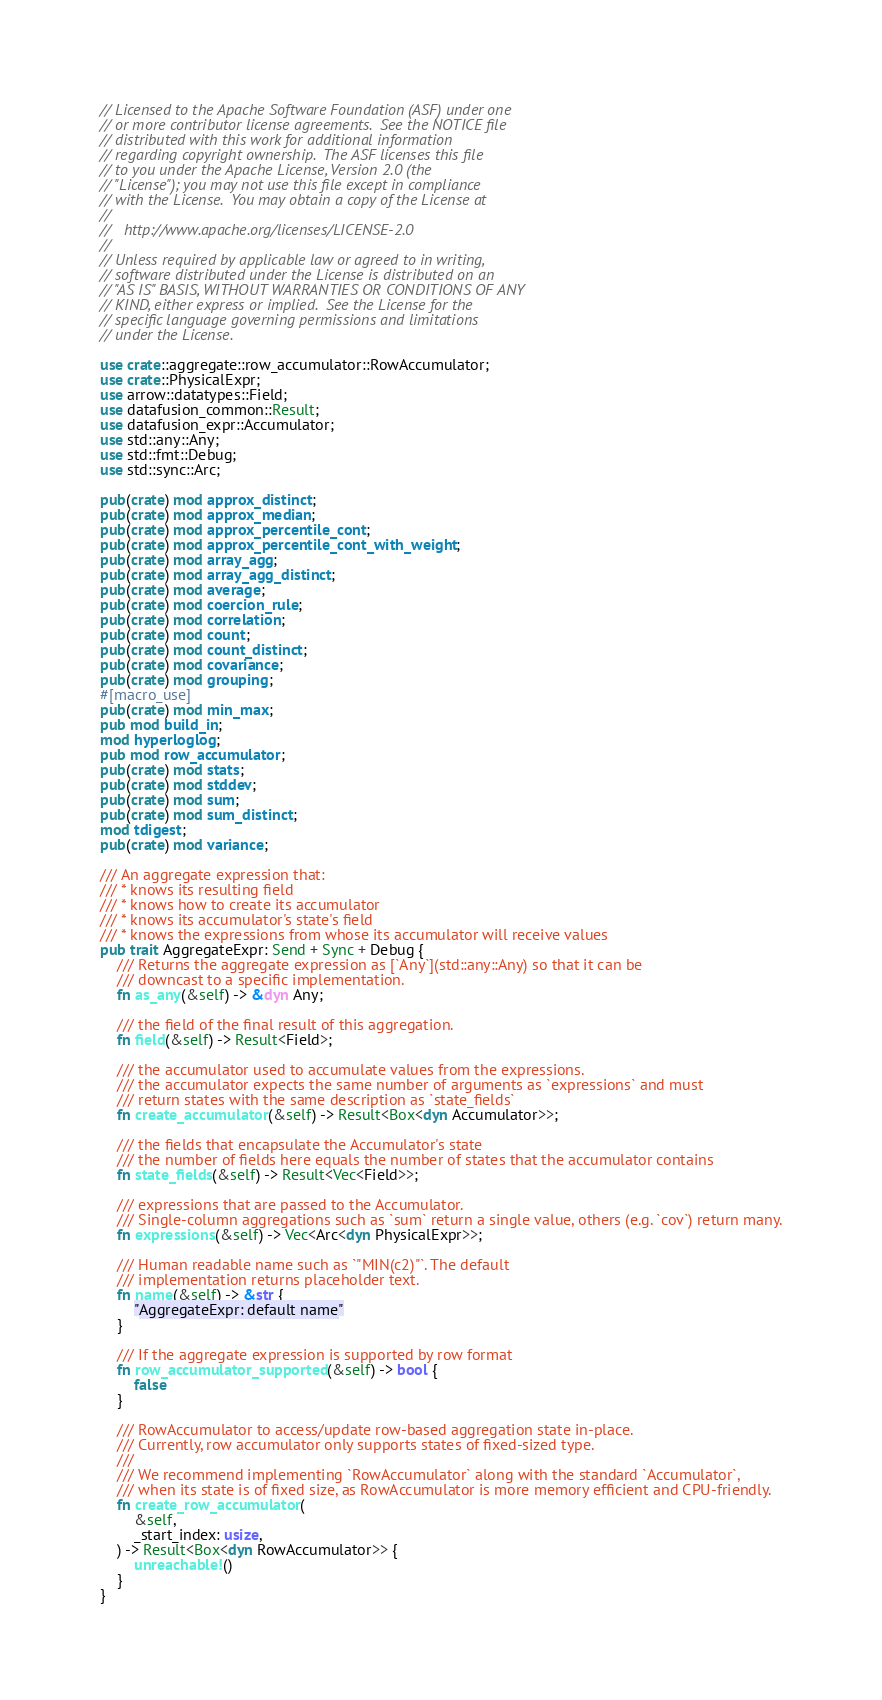<code> <loc_0><loc_0><loc_500><loc_500><_Rust_>// Licensed to the Apache Software Foundation (ASF) under one
// or more contributor license agreements.  See the NOTICE file
// distributed with this work for additional information
// regarding copyright ownership.  The ASF licenses this file
// to you under the Apache License, Version 2.0 (the
// "License"); you may not use this file except in compliance
// with the License.  You may obtain a copy of the License at
//
//   http://www.apache.org/licenses/LICENSE-2.0
//
// Unless required by applicable law or agreed to in writing,
// software distributed under the License is distributed on an
// "AS IS" BASIS, WITHOUT WARRANTIES OR CONDITIONS OF ANY
// KIND, either express or implied.  See the License for the
// specific language governing permissions and limitations
// under the License.

use crate::aggregate::row_accumulator::RowAccumulator;
use crate::PhysicalExpr;
use arrow::datatypes::Field;
use datafusion_common::Result;
use datafusion_expr::Accumulator;
use std::any::Any;
use std::fmt::Debug;
use std::sync::Arc;

pub(crate) mod approx_distinct;
pub(crate) mod approx_median;
pub(crate) mod approx_percentile_cont;
pub(crate) mod approx_percentile_cont_with_weight;
pub(crate) mod array_agg;
pub(crate) mod array_agg_distinct;
pub(crate) mod average;
pub(crate) mod coercion_rule;
pub(crate) mod correlation;
pub(crate) mod count;
pub(crate) mod count_distinct;
pub(crate) mod covariance;
pub(crate) mod grouping;
#[macro_use]
pub(crate) mod min_max;
pub mod build_in;
mod hyperloglog;
pub mod row_accumulator;
pub(crate) mod stats;
pub(crate) mod stddev;
pub(crate) mod sum;
pub(crate) mod sum_distinct;
mod tdigest;
pub(crate) mod variance;

/// An aggregate expression that:
/// * knows its resulting field
/// * knows how to create its accumulator
/// * knows its accumulator's state's field
/// * knows the expressions from whose its accumulator will receive values
pub trait AggregateExpr: Send + Sync + Debug {
    /// Returns the aggregate expression as [`Any`](std::any::Any) so that it can be
    /// downcast to a specific implementation.
    fn as_any(&self) -> &dyn Any;

    /// the field of the final result of this aggregation.
    fn field(&self) -> Result<Field>;

    /// the accumulator used to accumulate values from the expressions.
    /// the accumulator expects the same number of arguments as `expressions` and must
    /// return states with the same description as `state_fields`
    fn create_accumulator(&self) -> Result<Box<dyn Accumulator>>;

    /// the fields that encapsulate the Accumulator's state
    /// the number of fields here equals the number of states that the accumulator contains
    fn state_fields(&self) -> Result<Vec<Field>>;

    /// expressions that are passed to the Accumulator.
    /// Single-column aggregations such as `sum` return a single value, others (e.g. `cov`) return many.
    fn expressions(&self) -> Vec<Arc<dyn PhysicalExpr>>;

    /// Human readable name such as `"MIN(c2)"`. The default
    /// implementation returns placeholder text.
    fn name(&self) -> &str {
        "AggregateExpr: default name"
    }

    /// If the aggregate expression is supported by row format
    fn row_accumulator_supported(&self) -> bool {
        false
    }

    /// RowAccumulator to access/update row-based aggregation state in-place.
    /// Currently, row accumulator only supports states of fixed-sized type.
    ///
    /// We recommend implementing `RowAccumulator` along with the standard `Accumulator`,
    /// when its state is of fixed size, as RowAccumulator is more memory efficient and CPU-friendly.
    fn create_row_accumulator(
        &self,
        _start_index: usize,
    ) -> Result<Box<dyn RowAccumulator>> {
        unreachable!()
    }
}
</code> 